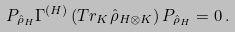Convert formula to latex. <formula><loc_0><loc_0><loc_500><loc_500>P _ { \hat { \rho } _ { H } } \Gamma ^ { ( H ) } \left ( { T r _ { K } \hat { \rho } _ { H \otimes K } } \right ) P _ { \hat { \rho } _ { H } } = 0 \, .</formula> 